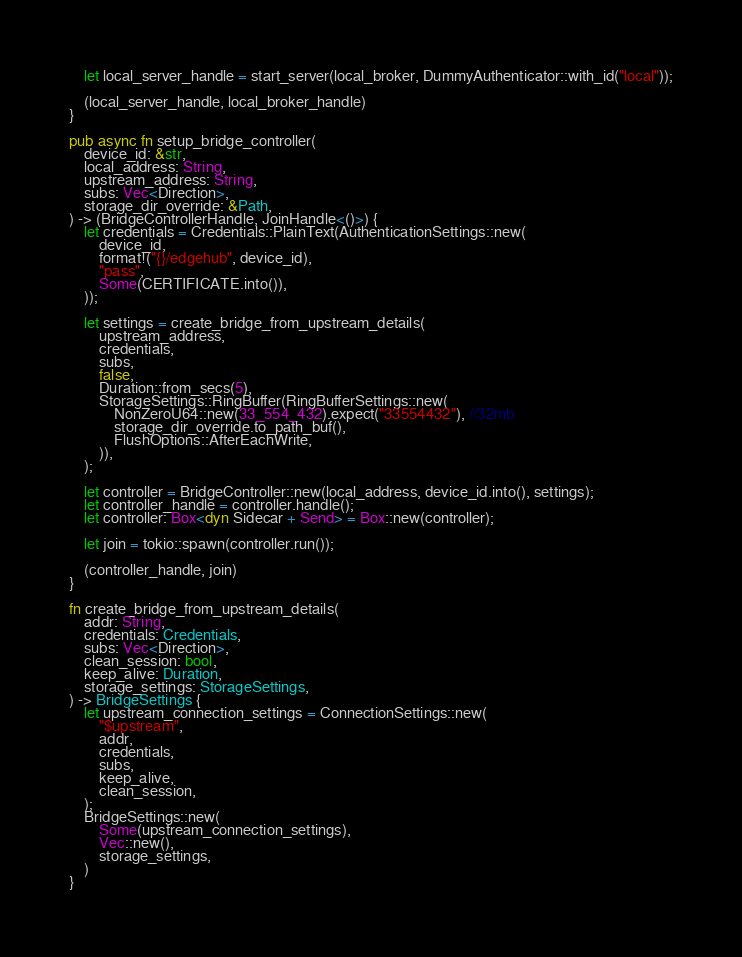<code> <loc_0><loc_0><loc_500><loc_500><_Rust_>    let local_server_handle = start_server(local_broker, DummyAuthenticator::with_id("local"));

    (local_server_handle, local_broker_handle)
}

pub async fn setup_bridge_controller(
    device_id: &str,
    local_address: String,
    upstream_address: String,
    subs: Vec<Direction>,
    storage_dir_override: &Path,
) -> (BridgeControllerHandle, JoinHandle<()>) {
    let credentials = Credentials::PlainText(AuthenticationSettings::new(
        device_id,
        format!("{}/edgehub", device_id),
        "pass",
        Some(CERTIFICATE.into()),
    ));

    let settings = create_bridge_from_upstream_details(
        upstream_address,
        credentials,
        subs,
        false,
        Duration::from_secs(5),
        StorageSettings::RingBuffer(RingBufferSettings::new(
            NonZeroU64::new(33_554_432).expect("33554432"), //32mb
            storage_dir_override.to_path_buf(),
            FlushOptions::AfterEachWrite,
        )),
    );

    let controller = BridgeController::new(local_address, device_id.into(), settings);
    let controller_handle = controller.handle();
    let controller: Box<dyn Sidecar + Send> = Box::new(controller);

    let join = tokio::spawn(controller.run());

    (controller_handle, join)
}

fn create_bridge_from_upstream_details(
    addr: String,
    credentials: Credentials,
    subs: Vec<Direction>,
    clean_session: bool,
    keep_alive: Duration,
    storage_settings: StorageSettings,
) -> BridgeSettings {
    let upstream_connection_settings = ConnectionSettings::new(
        "$upstream",
        addr,
        credentials,
        subs,
        keep_alive,
        clean_session,
    );
    BridgeSettings::new(
        Some(upstream_connection_settings),
        Vec::new(),
        storage_settings,
    )
}
</code> 